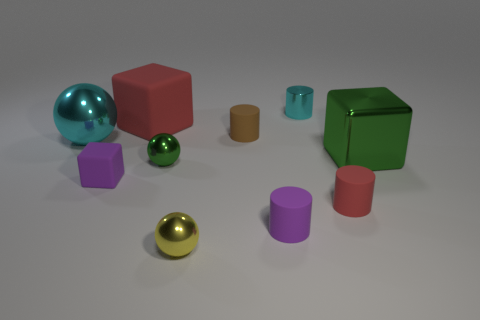There is a brown rubber object; is it the same size as the red matte object that is in front of the metal cube?
Your answer should be compact. Yes. What number of objects are tiny matte cylinders behind the big ball or tiny cyan things behind the tiny green ball?
Your answer should be compact. 2. There is a tiny shiny object that is behind the brown object; what color is it?
Keep it short and to the point. Cyan. Is there a large cube left of the tiny metallic ball on the left side of the small yellow object?
Keep it short and to the point. Yes. Are there fewer big gray metallic cubes than tiny green shiny spheres?
Your answer should be compact. Yes. What is the tiny purple thing behind the tiny cylinder in front of the red cylinder made of?
Your answer should be very brief. Rubber. Is the green sphere the same size as the red cube?
Give a very brief answer. No. How many objects are either green things or red cylinders?
Provide a short and direct response. 3. What size is the metallic object that is behind the big metallic block and in front of the metallic cylinder?
Your response must be concise. Large. Is the number of large cubes that are on the left side of the cyan metallic ball less than the number of green cylinders?
Make the answer very short. No. 